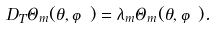<formula> <loc_0><loc_0><loc_500><loc_500>D _ { T } \Theta _ { m } ( \theta , \varphi ) = \lambda _ { m } \Theta _ { m } ( \theta , \varphi ) .</formula> 